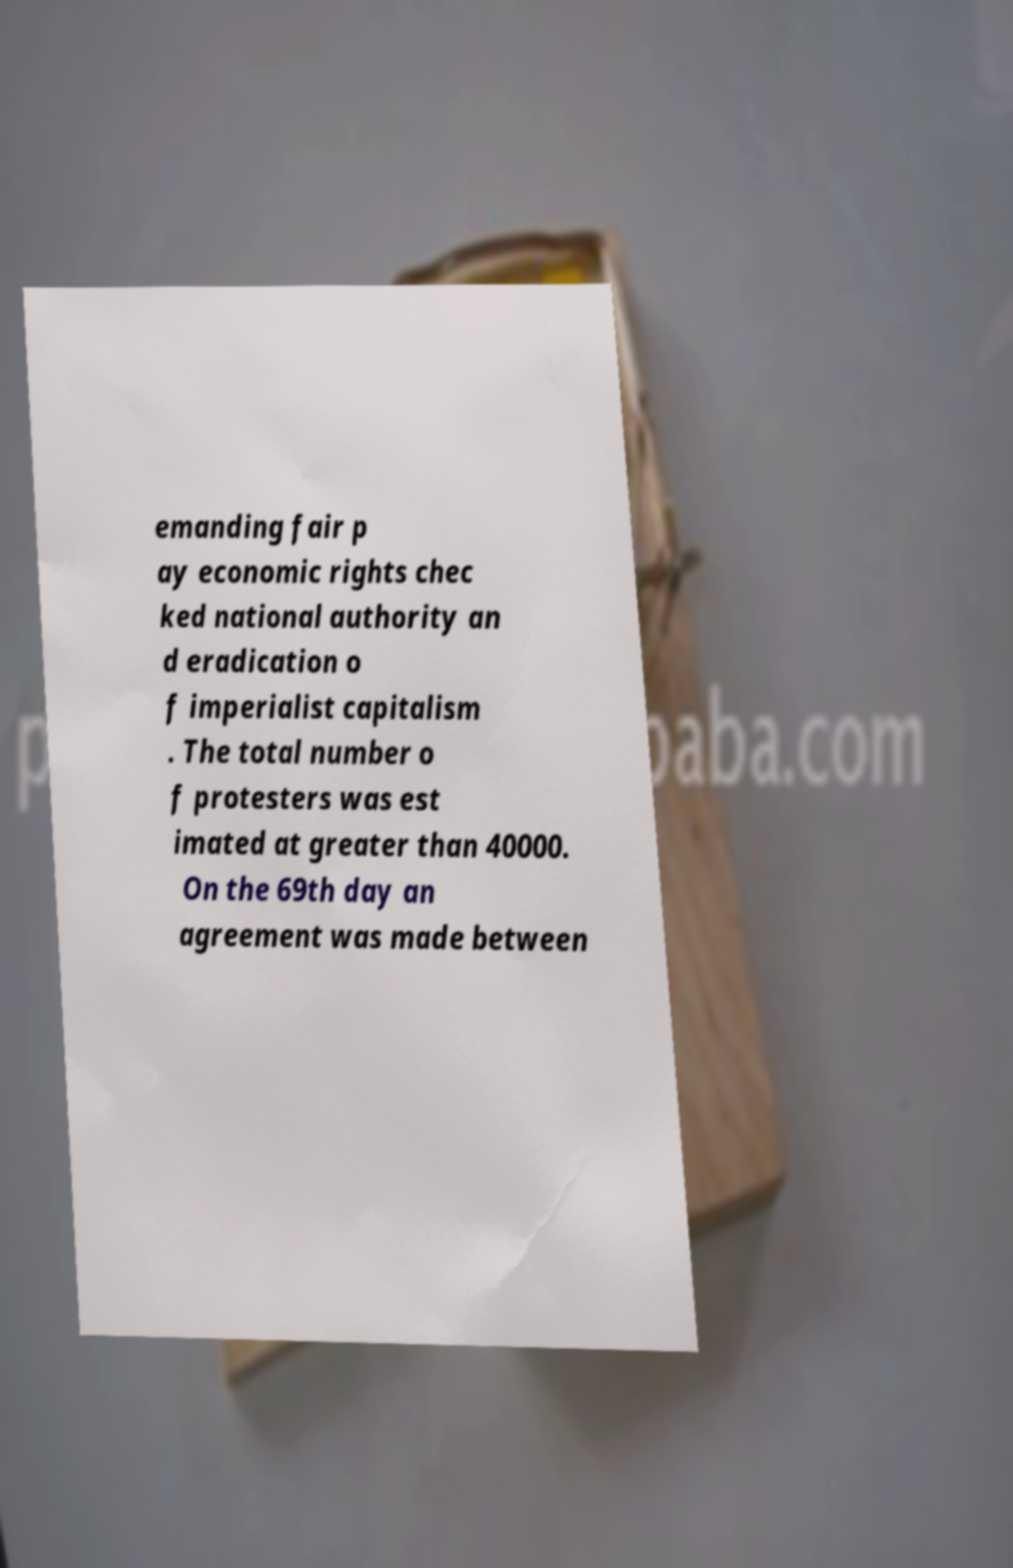Please read and relay the text visible in this image. What does it say? emanding fair p ay economic rights chec ked national authority an d eradication o f imperialist capitalism . The total number o f protesters was est imated at greater than 40000. On the 69th day an agreement was made between 